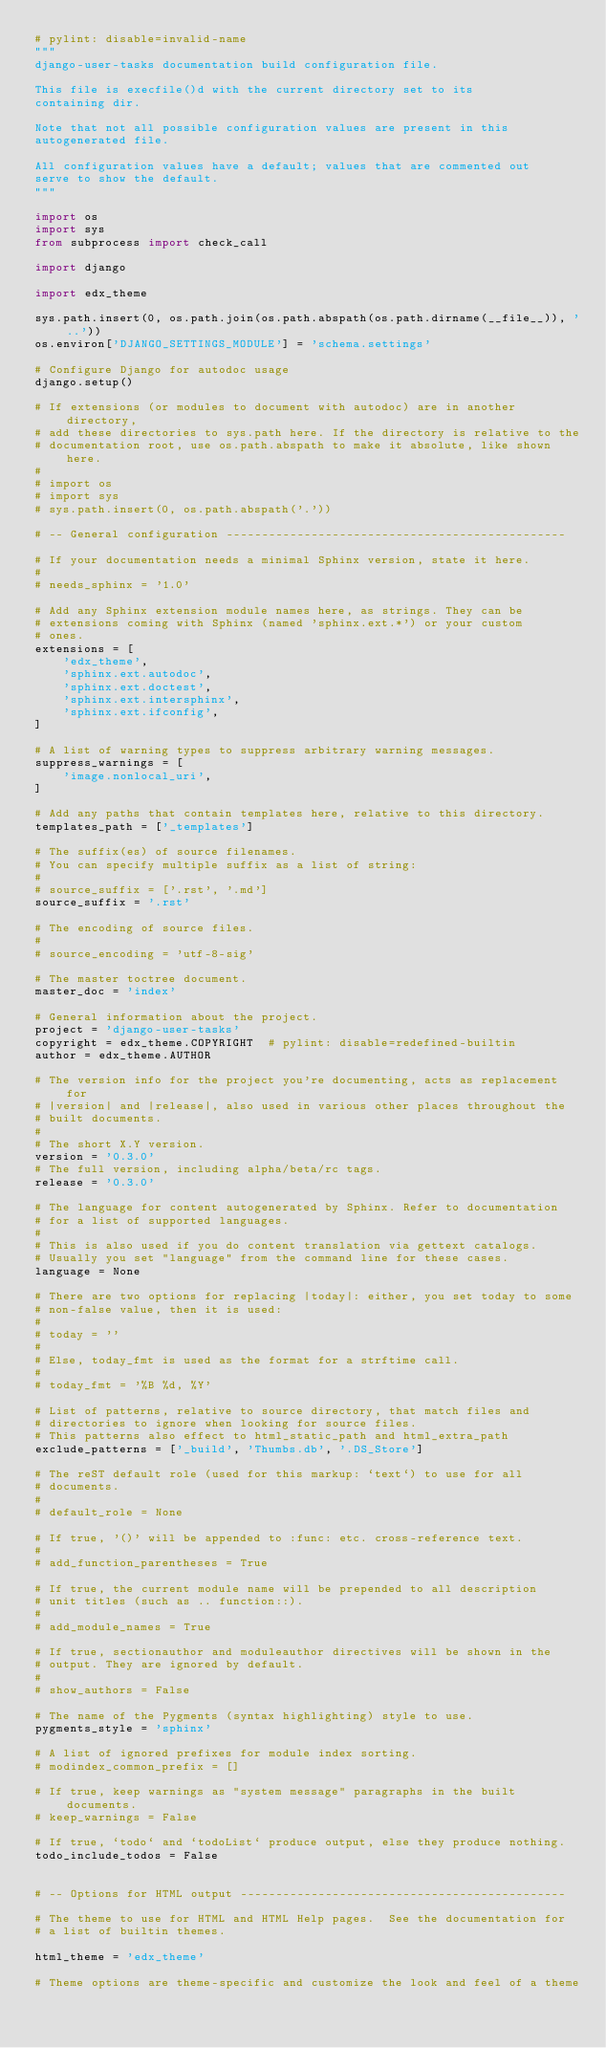Convert code to text. <code><loc_0><loc_0><loc_500><loc_500><_Python_># pylint: disable=invalid-name
"""
django-user-tasks documentation build configuration file.

This file is execfile()d with the current directory set to its
containing dir.

Note that not all possible configuration values are present in this
autogenerated file.

All configuration values have a default; values that are commented out
serve to show the default.
"""

import os
import sys
from subprocess import check_call

import django

import edx_theme

sys.path.insert(0, os.path.join(os.path.abspath(os.path.dirname(__file__)), '..'))
os.environ['DJANGO_SETTINGS_MODULE'] = 'schema.settings'

# Configure Django for autodoc usage
django.setup()

# If extensions (or modules to document with autodoc) are in another directory,
# add these directories to sys.path here. If the directory is relative to the
# documentation root, use os.path.abspath to make it absolute, like shown here.
#
# import os
# import sys
# sys.path.insert(0, os.path.abspath('.'))

# -- General configuration ------------------------------------------------

# If your documentation needs a minimal Sphinx version, state it here.
#
# needs_sphinx = '1.0'

# Add any Sphinx extension module names here, as strings. They can be
# extensions coming with Sphinx (named 'sphinx.ext.*') or your custom
# ones.
extensions = [
    'edx_theme',
    'sphinx.ext.autodoc',
    'sphinx.ext.doctest',
    'sphinx.ext.intersphinx',
    'sphinx.ext.ifconfig',
]

# A list of warning types to suppress arbitrary warning messages.
suppress_warnings = [
    'image.nonlocal_uri',
]

# Add any paths that contain templates here, relative to this directory.
templates_path = ['_templates']

# The suffix(es) of source filenames.
# You can specify multiple suffix as a list of string:
#
# source_suffix = ['.rst', '.md']
source_suffix = '.rst'

# The encoding of source files.
#
# source_encoding = 'utf-8-sig'

# The master toctree document.
master_doc = 'index'

# General information about the project.
project = 'django-user-tasks'
copyright = edx_theme.COPYRIGHT  # pylint: disable=redefined-builtin
author = edx_theme.AUTHOR

# The version info for the project you're documenting, acts as replacement for
# |version| and |release|, also used in various other places throughout the
# built documents.
#
# The short X.Y version.
version = '0.3.0'
# The full version, including alpha/beta/rc tags.
release = '0.3.0'

# The language for content autogenerated by Sphinx. Refer to documentation
# for a list of supported languages.
#
# This is also used if you do content translation via gettext catalogs.
# Usually you set "language" from the command line for these cases.
language = None

# There are two options for replacing |today|: either, you set today to some
# non-false value, then it is used:
#
# today = ''
#
# Else, today_fmt is used as the format for a strftime call.
#
# today_fmt = '%B %d, %Y'

# List of patterns, relative to source directory, that match files and
# directories to ignore when looking for source files.
# This patterns also effect to html_static_path and html_extra_path
exclude_patterns = ['_build', 'Thumbs.db', '.DS_Store']

# The reST default role (used for this markup: `text`) to use for all
# documents.
#
# default_role = None

# If true, '()' will be appended to :func: etc. cross-reference text.
#
# add_function_parentheses = True

# If true, the current module name will be prepended to all description
# unit titles (such as .. function::).
#
# add_module_names = True

# If true, sectionauthor and moduleauthor directives will be shown in the
# output. They are ignored by default.
#
# show_authors = False

# The name of the Pygments (syntax highlighting) style to use.
pygments_style = 'sphinx'

# A list of ignored prefixes for module index sorting.
# modindex_common_prefix = []

# If true, keep warnings as "system message" paragraphs in the built documents.
# keep_warnings = False

# If true, `todo` and `todoList` produce output, else they produce nothing.
todo_include_todos = False


# -- Options for HTML output ----------------------------------------------

# The theme to use for HTML and HTML Help pages.  See the documentation for
# a list of builtin themes.

html_theme = 'edx_theme'

# Theme options are theme-specific and customize the look and feel of a theme</code> 